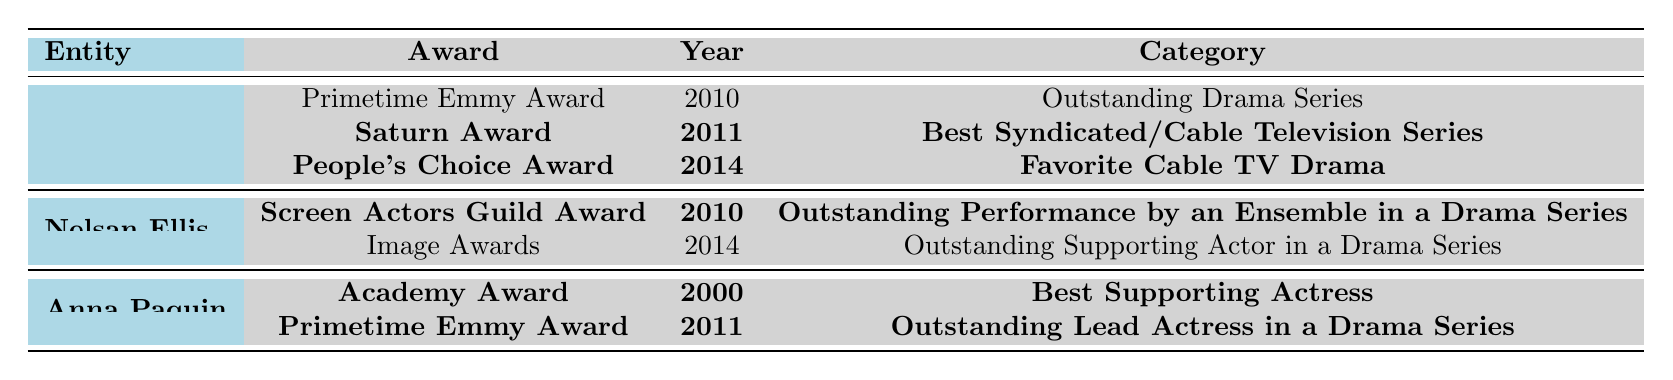What is the title of the TV series associated with Nelsan Ellis? The table indicates that Nelsan Ellis was involved with the TV series **True Blood**.
Answer: True Blood How many awards did the TV series **True Blood** win? The table shows that **True Blood** won **three** awards in total (two from the TV series section and one from the ensemble cast).
Answer: 3 Which award did Anna Paquin win for her role in **True Blood**? The table indicates that Anna Paquin won the **Primetime Emmy Award** in **2011** for her role in **True Blood**.
Answer: Primetime Emmy Award Did Nelsan Ellis win the Image Awards? The table shows that Nelsan Ellis did not win the Image Awards in **2014**.
Answer: No What was the category of the award won by **True Blood** in **2011**? The table indicates that the award won in **2011** was the **Saturn Award** for **Best Syndicated/Cable Television Series**.
Answer: Best Syndicated/Cable Television Series How many awards did Anna Paquin win compared to Nelsan Ellis? Anna Paquin won **two** awards, whereas Nelsan Ellis won **one** award. Thus, Anna Paquin has won more awards than Nelsan Ellis.
Answer: Anna Paquin has won more Which actor received an award in **2010**? Both Nelsan Ellis and the TV series **True Blood** received awards in **2010**; Nelsan Ellis won the **Screen Actors Guild Award**, and **True Blood** was nominated for the **Primetime Emmy Award**.
Answer: Two entities (Nelsan Ellis & True Blood) What type of award is the Screen Actors Guild Award? The Screen Actors Guild Award for Nelsan Ellis in **2010** is classified under **Outstanding Performance by an Ensemble in a Drama Series**.
Answer: Ensemble performance award Which award won by **True Blood** has the category "Favorite Cable TV Drama"? The table states that the **People's Choice Award** won in **2014** is categorized as **Favorite Cable TV Drama**.
Answer: People's Choice Award What is the total number of awards won by the actors listed? Nelsan Ellis won **one** award and Anna Paquin won **two** awards, resulting in a total of **three** awards won by actors listed in the table.
Answer: 3 Which year did Anna Paquin win the Academy Award? According to the table, Anna Paquin won the **Academy Award** in **2000**.
Answer: 2000 What was the outcome of the Primetime Emmy Award for **True Blood** in **2010**? The table indicates that **True Blood** was **nominated** for the Primetime Emmy Award in **2010** but did not win.
Answer: Nominated, did not win 